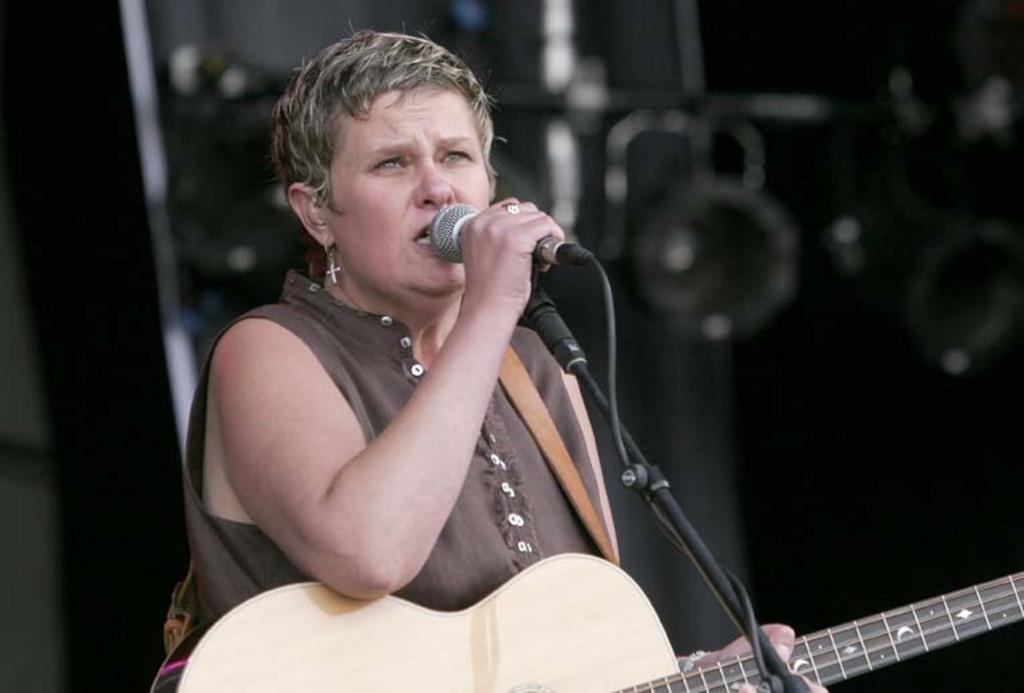Who is the main subject in the image? There is a woman in the image. What is the woman holding in the image? The woman is holding a microphone and a guitar. What is the woman wearing in the image? The woman is wearing a brown dress. Where is the throne located in the image? There is no throne present in the image. How many rabbits can be seen in the image? There are no rabbits present in the image. 